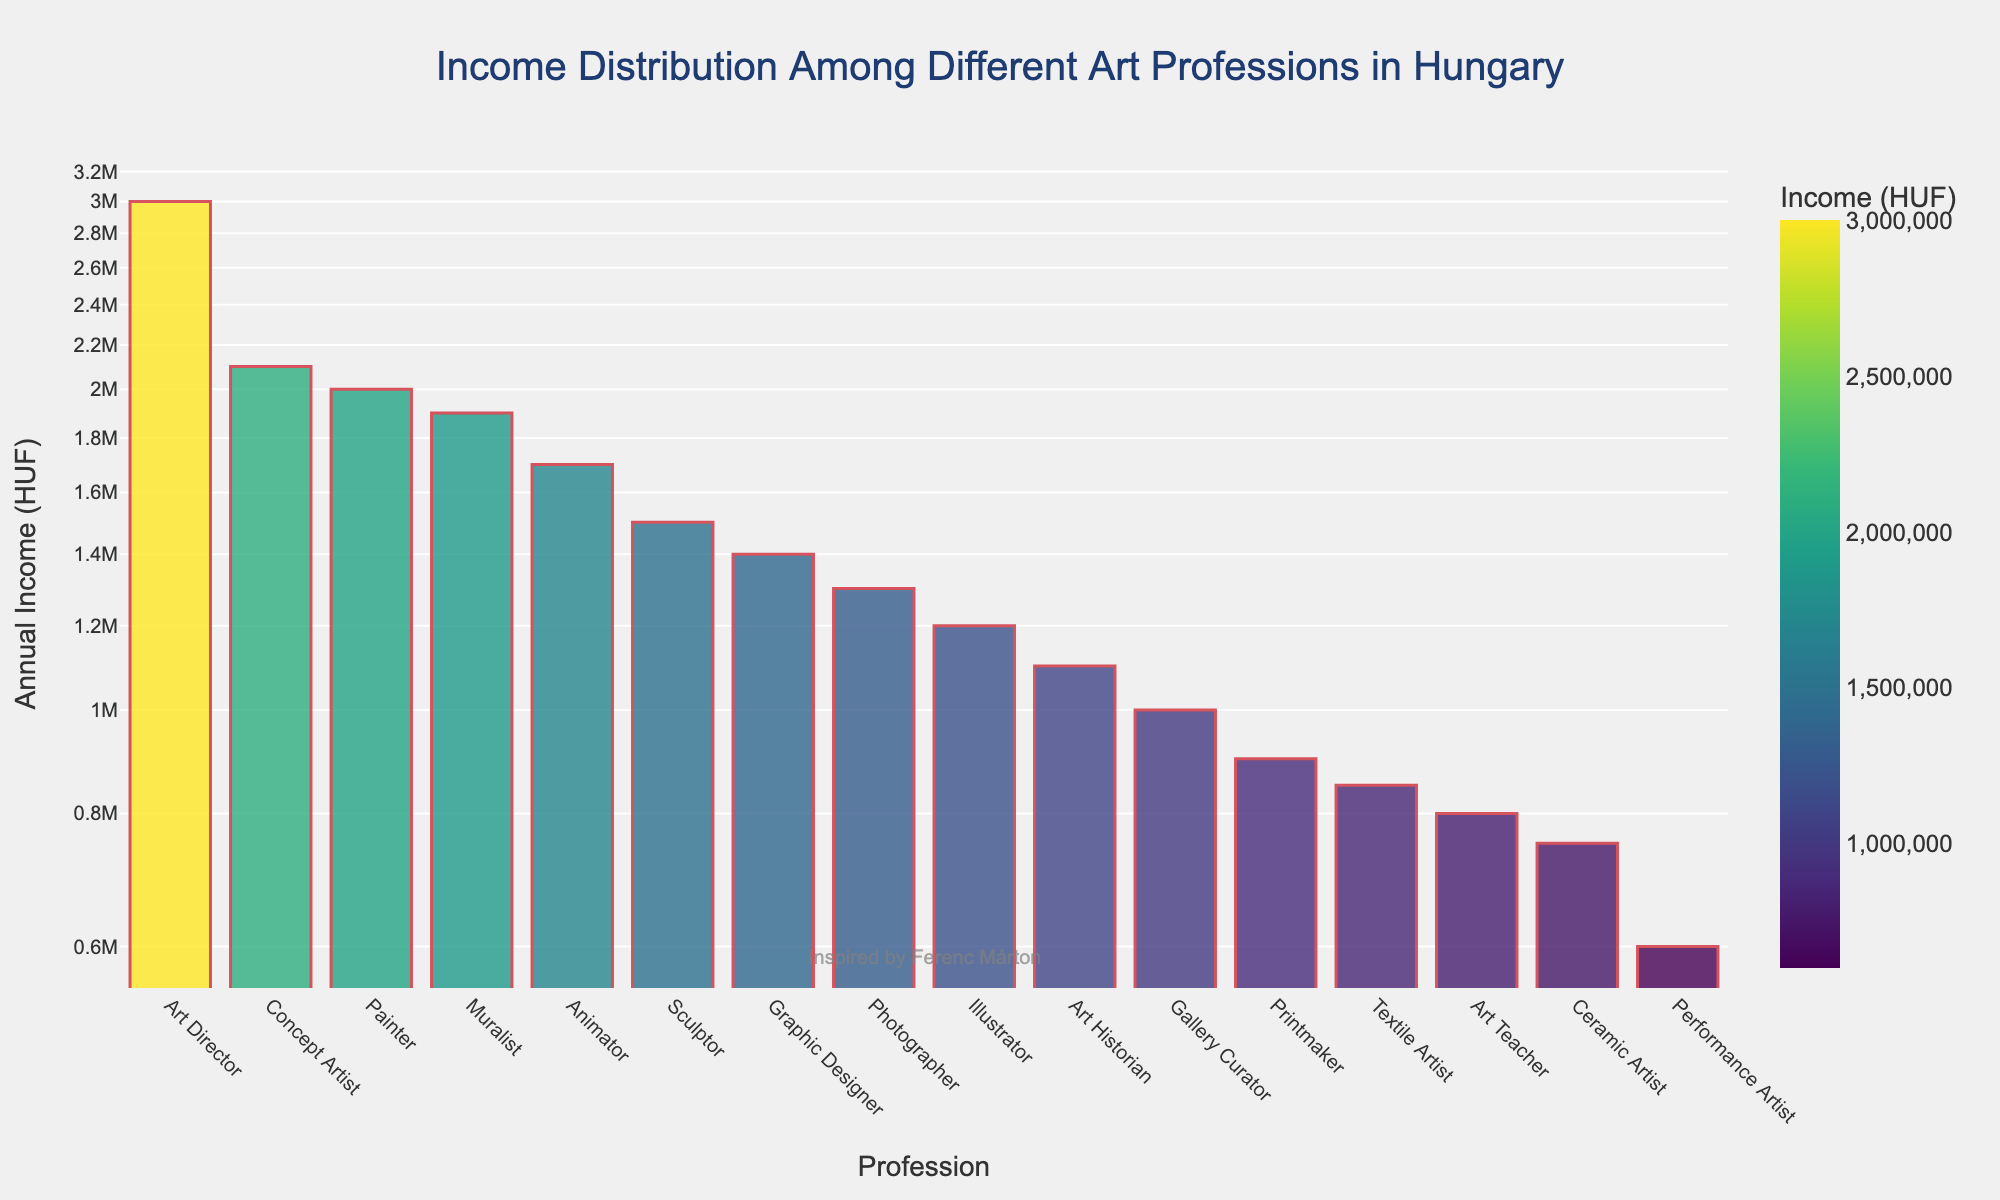What's the highest earning profession among the art-related professions? By looking at the bar chart, the profession with the highest bar represents the highest earning profession. The highest earning profession on this chart is the Art Director, with an income of 3,000,000 HUF.
Answer: Art Director What is the title of the plot? The title is typically found at the top of the plot. In this plot, it reads "Income Distribution Among Different Art Professions in Hungary".
Answer: Income Distribution Among Different Art Professions in Hungary Which profession has a higher income: Animator or Illustrator? By comparing the heights of the bars labeled Animator and Illustrator, it is evident that the Animator bar is higher than the Illustrator bar, indicating a higher income. Animator's income is 1,700,000 HUF, while Illustrator's is 1,200,000 HUF.
Answer: Animator What is the income difference between Art Director and Muralist? To find the income difference, subtract the Muralist's income from the Art Director's income. Art Director earns 3,000,000 HUF, and Muralist earns 1,900,000 HUF. The difference is 3,000,000 - 1,900,000 = 1,100,000 HUF.
Answer: 1,100,000 HUF Which profession has the smallest annual income, and what is it? The profession with the lowest bar corresponds to the smallest annual income. The Performance Artist has the smallest income at 600,000 HUF.
Answer: Performance Artist, 600,000 HUF What's the combined income of Art Teacher, Gallery Curator, and Art Historian? To determine the combined income, add the incomes of Art Teacher (800,000 HUF), Gallery Curator (1,000,000 HUF), and Art Historian (1,100,000 HUF). The sum is 800,000 + 1,000,000 + 1,100,000 = 2,900,000 HUF.
Answer: 2,900,000 HUF How much more does an Art Director make compared to an Art Teacher? Determine the income difference by subtracting the Art Teacher's income from the Art Director's income. The Art Director's income is 3,000,000 HUF, and the Art Teacher's is 800,000 HUF. The difference is 3,000,000 - 800,000 = 2,200,000 HUF.
Answer: 2,200,000 HUF What is the median income level among all the art-related professions in the plot? To find the median income, first, list all incomes in ascending order: [600,000, 750,000, 800,000, 850,000, 900,000, 1,000,000, 1,100,000, 1,200,000, 1,300,000, 1,400,000, 1,500,000, 1,700,000, 1,900,000, 2,000,000, 2,100,000, 3,000,000]. With 16 values, the median is the average of the 8th and 9th values: (1,200,000 + 1,300,000) / 2 = 1,250,000 HUF.
Answer: 1,250,000 HUF How does the income of a Concept Artist compare to that of a Graphic Designer? By comparing the bar heights, the Concept Artist's income (2,100,000 HUF) is greater than the Graphic Designer's income (1,400,000 HUF).
Answer: Concept Artist earns more What's the log scale's impact on how the differences in incomes are presented? On a log scale axis, the differences in lower-income values appear more pronounced, whereas, for higher-income values, differences are compressed, ensuring a uniform distribution of data points across a wide range of values and improving readability of wide-ranging income differences.
Answer: Compresses high differences, expands low differences 